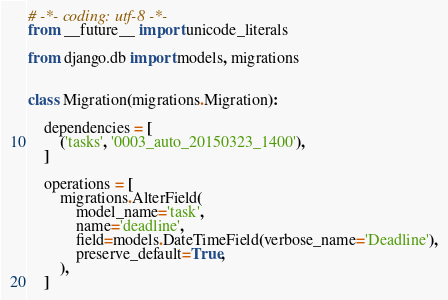<code> <loc_0><loc_0><loc_500><loc_500><_Python_># -*- coding: utf-8 -*-
from __future__ import unicode_literals

from django.db import models, migrations


class Migration(migrations.Migration):

    dependencies = [
        ('tasks', '0003_auto_20150323_1400'),
    ]

    operations = [
        migrations.AlterField(
            model_name='task',
            name='deadline',
            field=models.DateTimeField(verbose_name='Deadline'),
            preserve_default=True,
        ),
    ]
</code> 